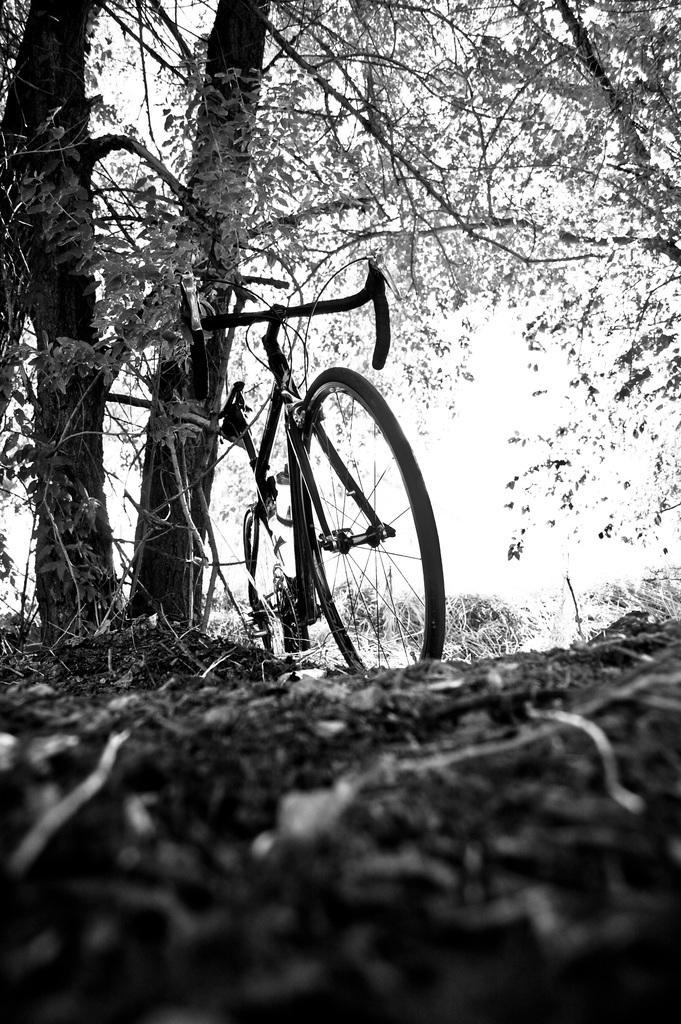How would you summarize this image in a sentence or two? This is a black and white image. In this image we can see a cycle. Also there are trees. In the background there is sky. 